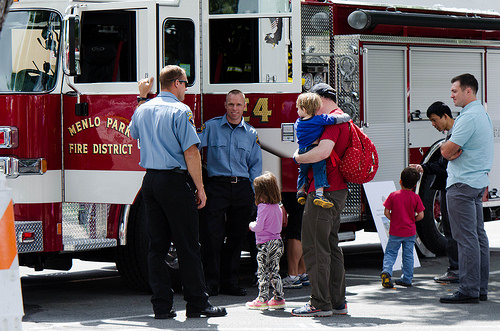<image>
Is there a kid next to the stairs? No. The kid is not positioned next to the stairs. They are located in different areas of the scene. 